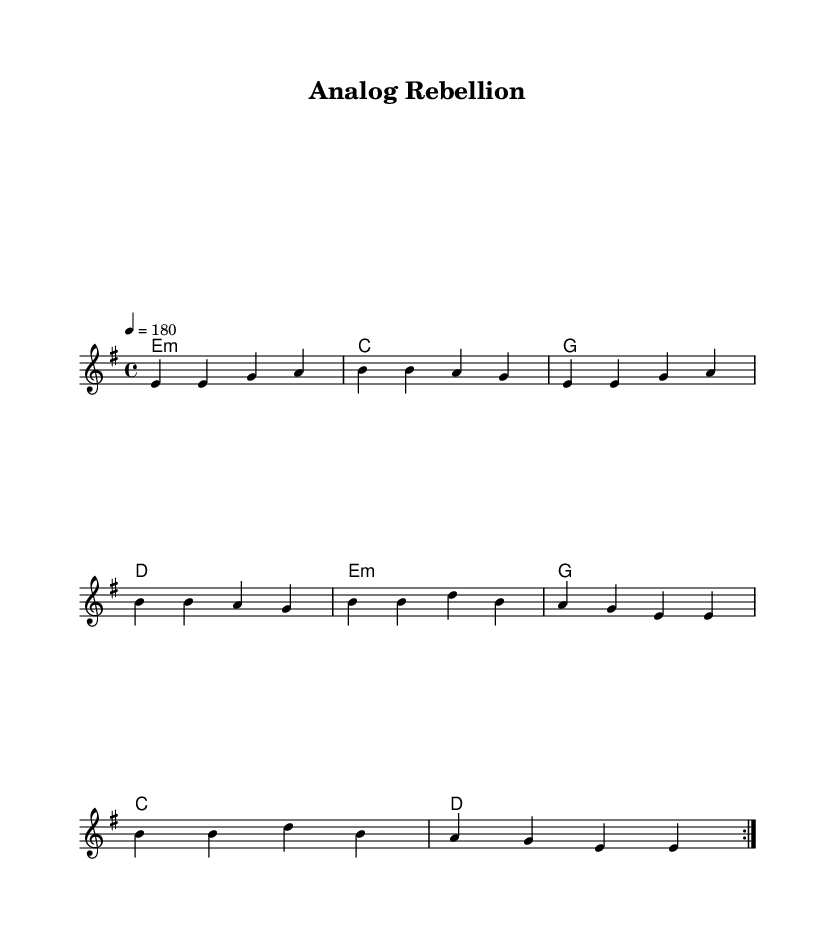What is the key signature of this music? The key signature is E minor, which has one sharp (F#). It is indicated at the beginning of the staff where the accidentals are shown.
Answer: E minor What is the time signature of the piece? The time signature is 4/4, which means there are four beats in each measure and a quarter note receives one beat. It is displayed at the beginning of the music along with the key signature.
Answer: 4/4 What is the tempo marking for the music? The tempo marking is 180, indicating the music should be played at this metronome speed (beats per minute) and is specified above the staff.
Answer: 180 How many times is the verse repeated? The verse section is marked with "volta 2", indicating it repeats two times as specified in the music notation.
Answer: 2 What is the primary theme of the lyrics? The lyrics express nostalgia for physical books and criticize the digital takeover of libraries. The lyrics mention dusty shelves, glowing screens, and the loss of the soul of a library, highlighting a resistance against the digital trend.
Answer: Critique of digitalization What type of harmony is used in the piece? The harmony used is based on common chords, with E minor, C major, G major, and D major being played in a basic progression. These chords support the melody and are typical in rock music.
Answer: Common chords What does the chorus emphasize in the context of punk rock? The chorus emphasizes resistance against the digital transformation, calling for recognition of analog truths amid a digital takeover. This aligns with the punk rock ethos of rebellion against societal changes.
Answer: Resistance against digital takeover 